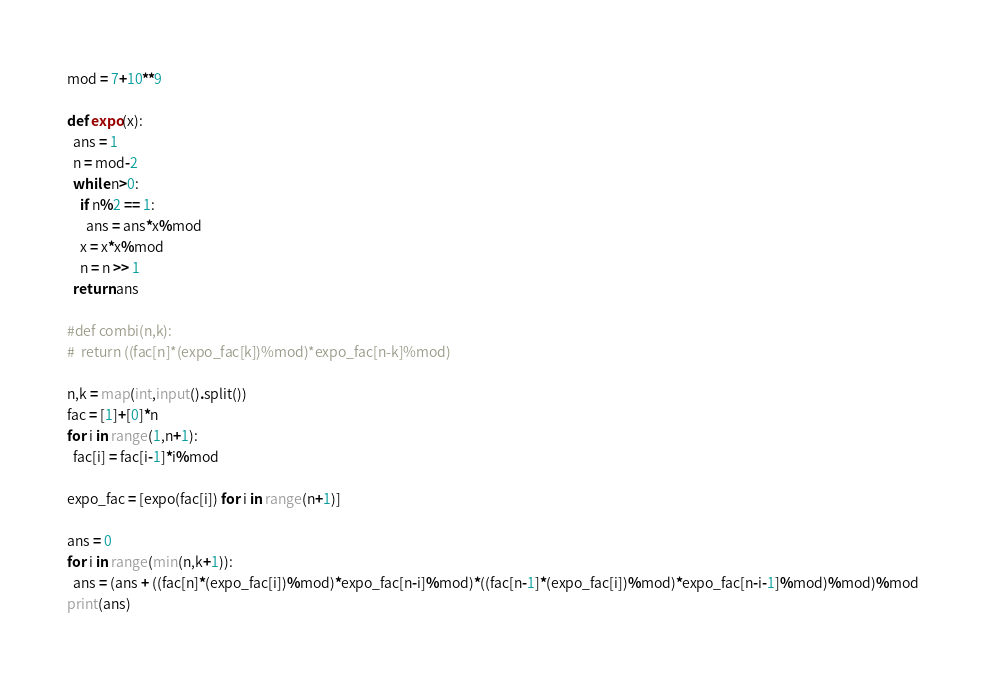Convert code to text. <code><loc_0><loc_0><loc_500><loc_500><_Python_>mod = 7+10**9

def expo(x):
  ans = 1
  n = mod-2
  while n>0:
    if n%2 == 1:
      ans = ans*x%mod
    x = x*x%mod
    n = n >> 1
  return ans

#def combi(n,k):
#  return ((fac[n]*(expo_fac[k])%mod)*expo_fac[n-k]%mod)

n,k = map(int,input().split())
fac = [1]+[0]*n
for i in range(1,n+1):
  fac[i] = fac[i-1]*i%mod

expo_fac = [expo(fac[i]) for i in range(n+1)]

ans = 0
for i in range(min(n,k+1)):
  ans = (ans + ((fac[n]*(expo_fac[i])%mod)*expo_fac[n-i]%mod)*((fac[n-1]*(expo_fac[i])%mod)*expo_fac[n-i-1]%mod)%mod)%mod
print(ans)</code> 